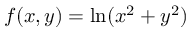Convert formula to latex. <formula><loc_0><loc_0><loc_500><loc_500>\, f ( x , y ) = \ln ( x ^ { 2 } + y ^ { 2 } )</formula> 